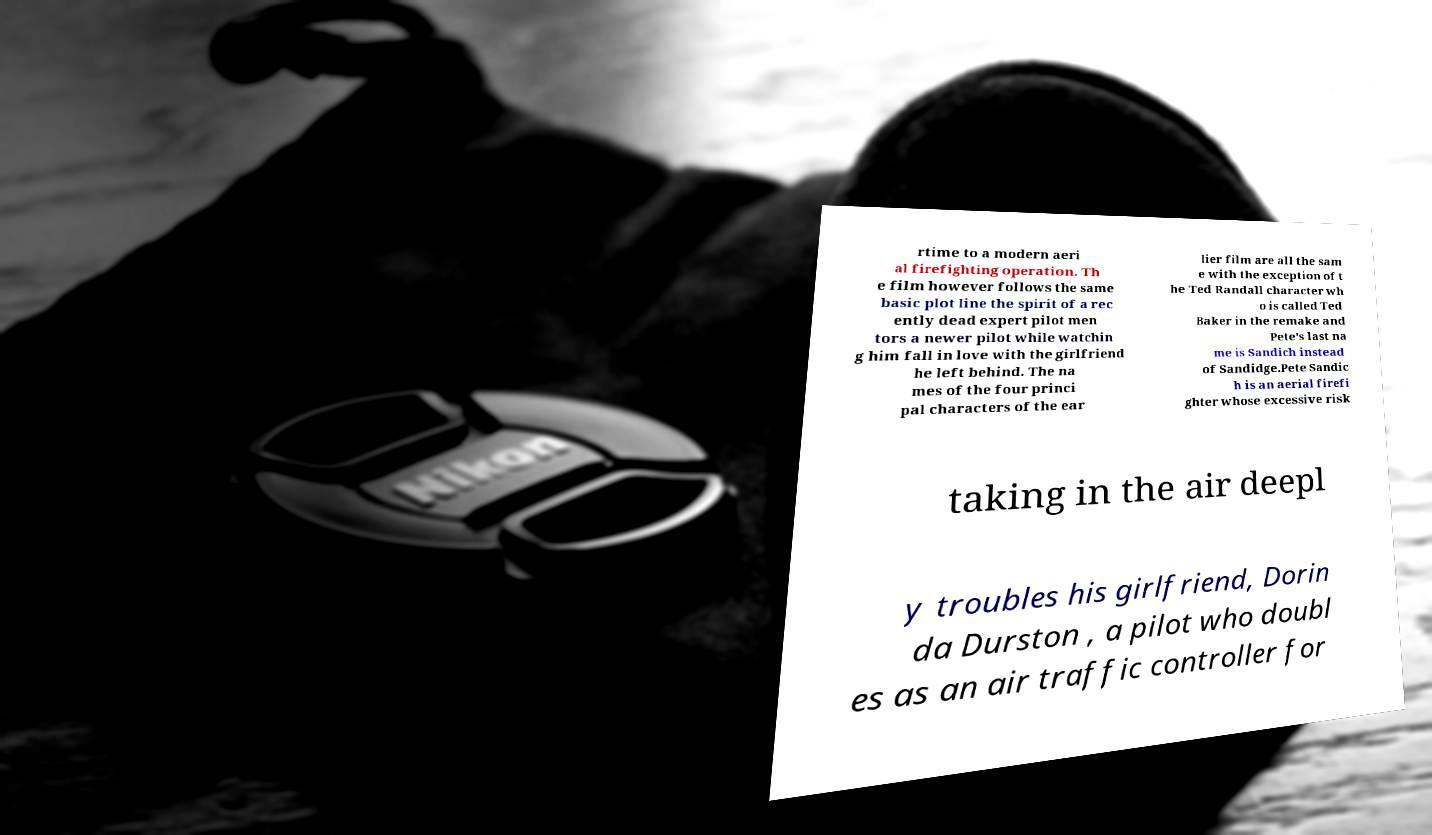There's text embedded in this image that I need extracted. Can you transcribe it verbatim? rtime to a modern aeri al firefighting operation. Th e film however follows the same basic plot line the spirit of a rec ently dead expert pilot men tors a newer pilot while watchin g him fall in love with the girlfriend he left behind. The na mes of the four princi pal characters of the ear lier film are all the sam e with the exception of t he Ted Randall character wh o is called Ted Baker in the remake and Pete's last na me is Sandich instead of Sandidge.Pete Sandic h is an aerial firefi ghter whose excessive risk taking in the air deepl y troubles his girlfriend, Dorin da Durston , a pilot who doubl es as an air traffic controller for 